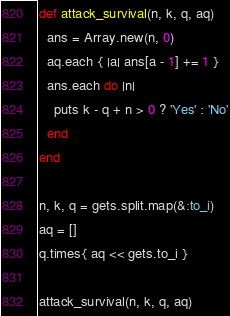<code> <loc_0><loc_0><loc_500><loc_500><_Ruby_>def attack_survival(n, k, q, aq)
  ans = Array.new(n, 0)
  aq.each { |a| ans[a - 1] += 1 }
  ans.each do |n|
    puts k - q + n > 0 ? 'Yes' : 'No'
  end
end

n, k, q = gets.split.map(&:to_i)
aq = []
q.times{ aq << gets.to_i }

attack_survival(n, k, q, aq)
</code> 